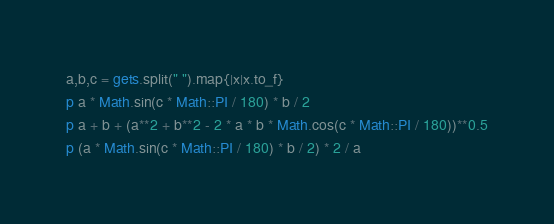Convert code to text. <code><loc_0><loc_0><loc_500><loc_500><_Ruby_>a,b,c = gets.split(" ").map{|x|x.to_f}
p a * Math.sin(c * Math::PI / 180) * b / 2
p a + b + (a**2 + b**2 - 2 * a * b * Math.cos(c * Math::PI / 180))**0.5
p (a * Math.sin(c * Math::PI / 180) * b / 2) * 2 / a</code> 